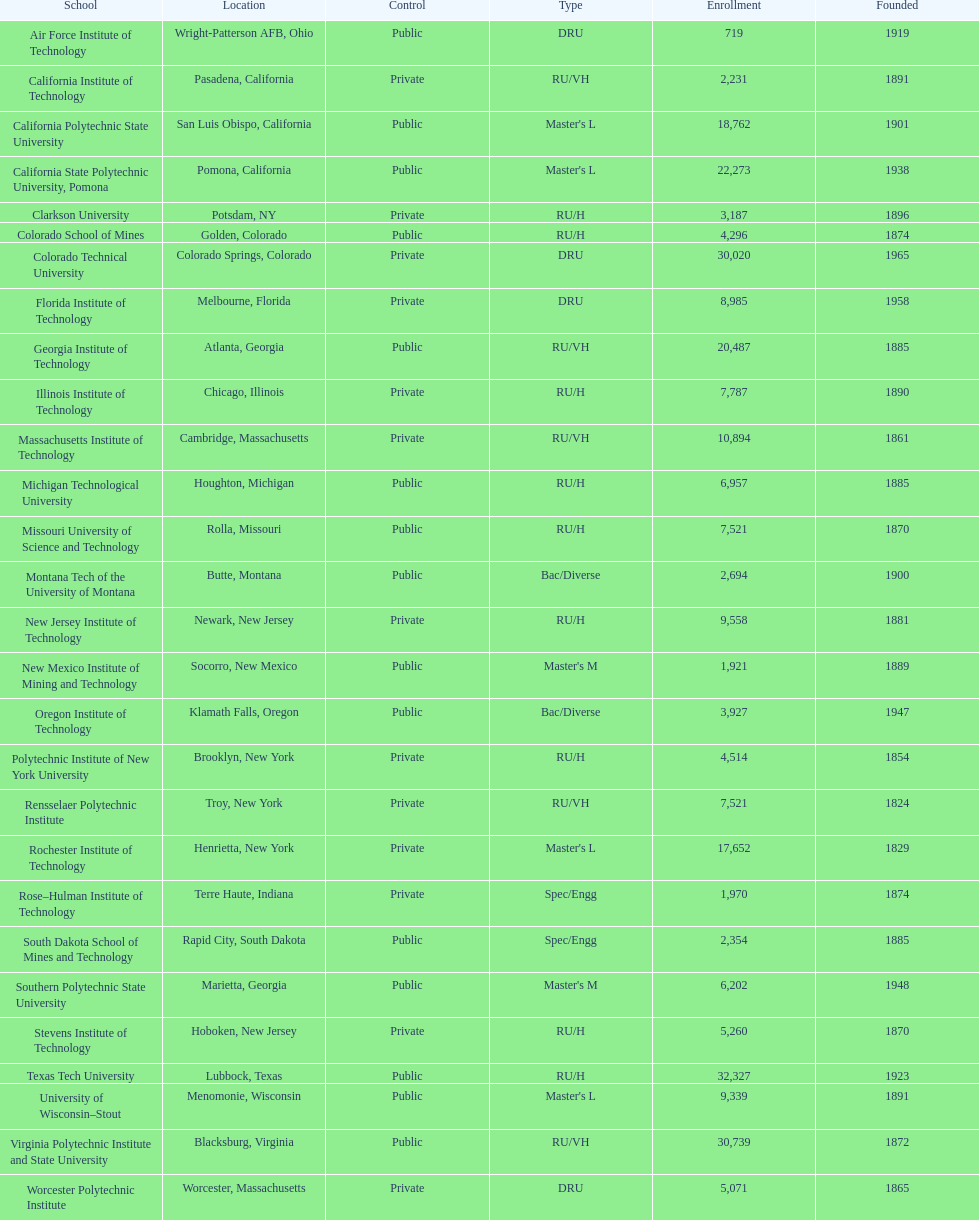What are the listed enrollment numbers of us universities? 719, 2,231, 18,762, 22,273, 3,187, 4,296, 30,020, 8,985, 20,487, 7,787, 10,894, 6,957, 7,521, 2,694, 9,558, 1,921, 3,927, 4,514, 7,521, 17,652, 1,970, 2,354, 6,202, 5,260, 32,327, 9,339, 30,739, 5,071. Of these, which has the highest value? 32,327. What are the listed names of us universities? Air Force Institute of Technology, California Institute of Technology, California Polytechnic State University, California State Polytechnic University, Pomona, Clarkson University, Colorado School of Mines, Colorado Technical University, Florida Institute of Technology, Georgia Institute of Technology, Illinois Institute of Technology, Massachusetts Institute of Technology, Michigan Technological University, Missouri University of Science and Technology, Montana Tech of the University of Montana, New Jersey Institute of Technology, New Mexico Institute of Mining and Technology, Oregon Institute of Technology, Polytechnic Institute of New York University, Rensselaer Polytechnic Institute, Rochester Institute of Technology, Rose–Hulman Institute of Technology, South Dakota School of Mines and Technology, Southern Polytechnic State University, Stevens Institute of Technology, Texas Tech University, University of Wisconsin–Stout, Virginia Polytechnic Institute and State University, Worcester Polytechnic Institute. Which of these correspond to the previously listed highest enrollment value? Texas Tech University. 